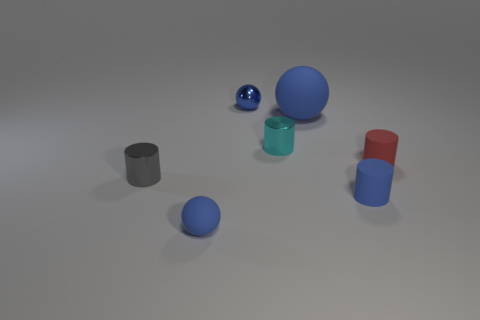Subtract all small blue spheres. How many spheres are left? 1 Subtract 1 cylinders. How many cylinders are left? 3 Subtract all red cylinders. How many cylinders are left? 3 Subtract all yellow cylinders. Subtract all purple spheres. How many cylinders are left? 4 Add 2 blue rubber things. How many objects exist? 9 Subtract all cylinders. How many objects are left? 3 Subtract all cyan things. Subtract all small blue cylinders. How many objects are left? 5 Add 3 small blue objects. How many small blue objects are left? 6 Add 4 rubber spheres. How many rubber spheres exist? 6 Subtract 0 green cylinders. How many objects are left? 7 